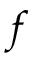<formula> <loc_0><loc_0><loc_500><loc_500>f</formula> 